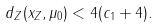Convert formula to latex. <formula><loc_0><loc_0><loc_500><loc_500>d _ { Z } ( x _ { Z } , \mu _ { 0 } ) < 4 ( c _ { 1 } + 4 ) .</formula> 